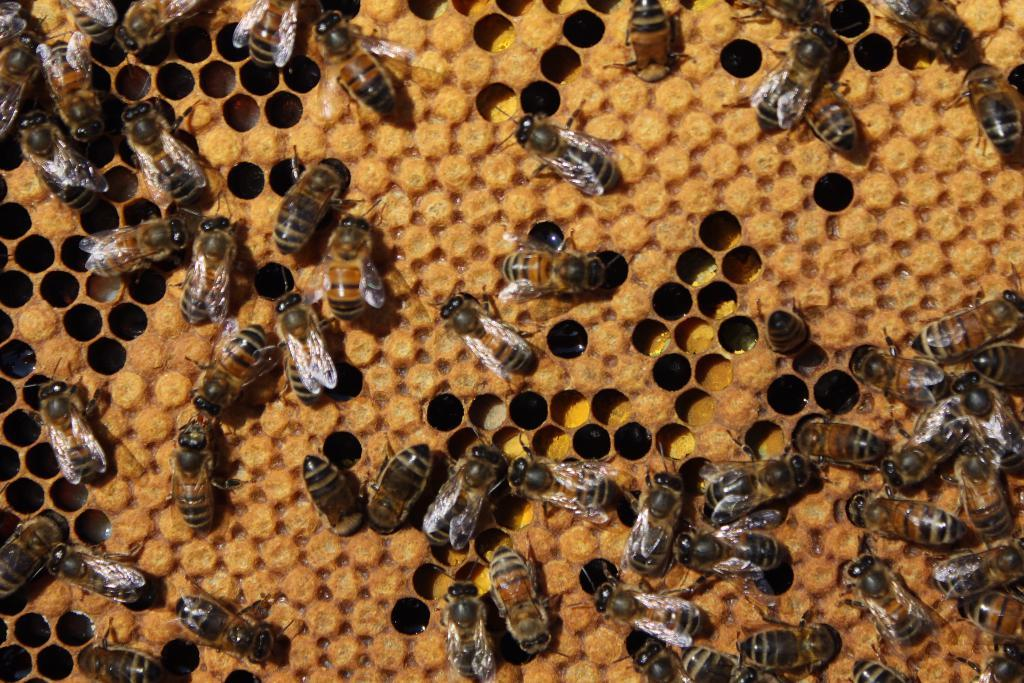What insects can be seen in the image? There are honeybees in the image. Where are the honeybees located? The honeybees are on a honeycomb. What is the color of the honeycomb? The honeycomb is in cream color. Are there any specific features on the honeycomb? Yes, there are holes on the honeycomb. What type of apparatus is used to extract juice from the honeycomb in the image? There is no apparatus present in the image, nor is there any juice extraction taking place. 